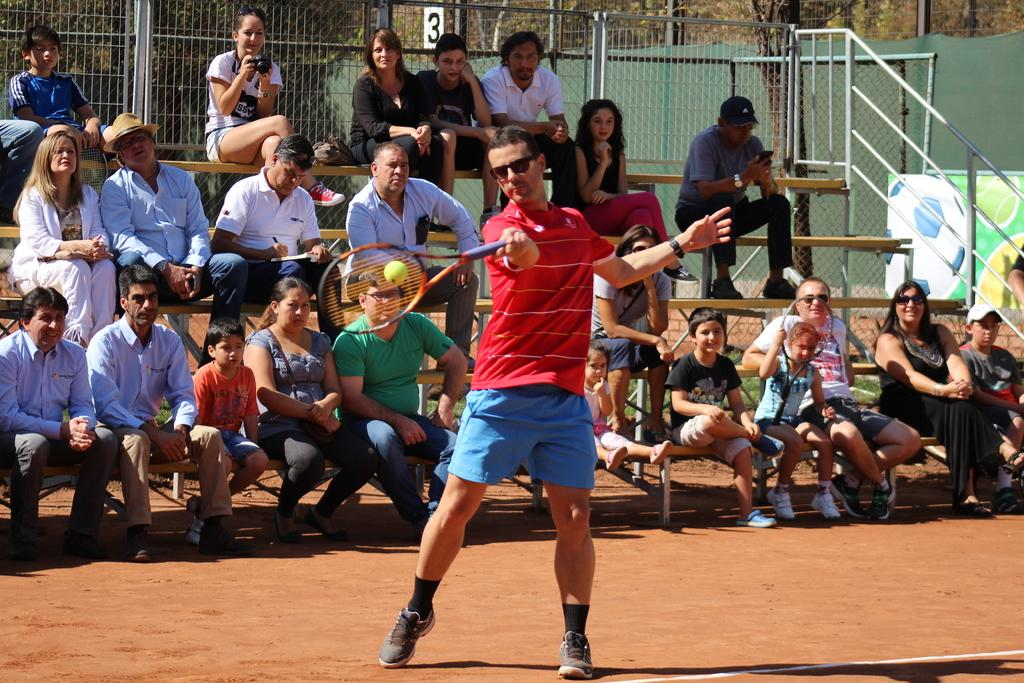<image>
Relay a brief, clear account of the picture shown. Spectators sit in front of a little white sign with the number 3 on it. 